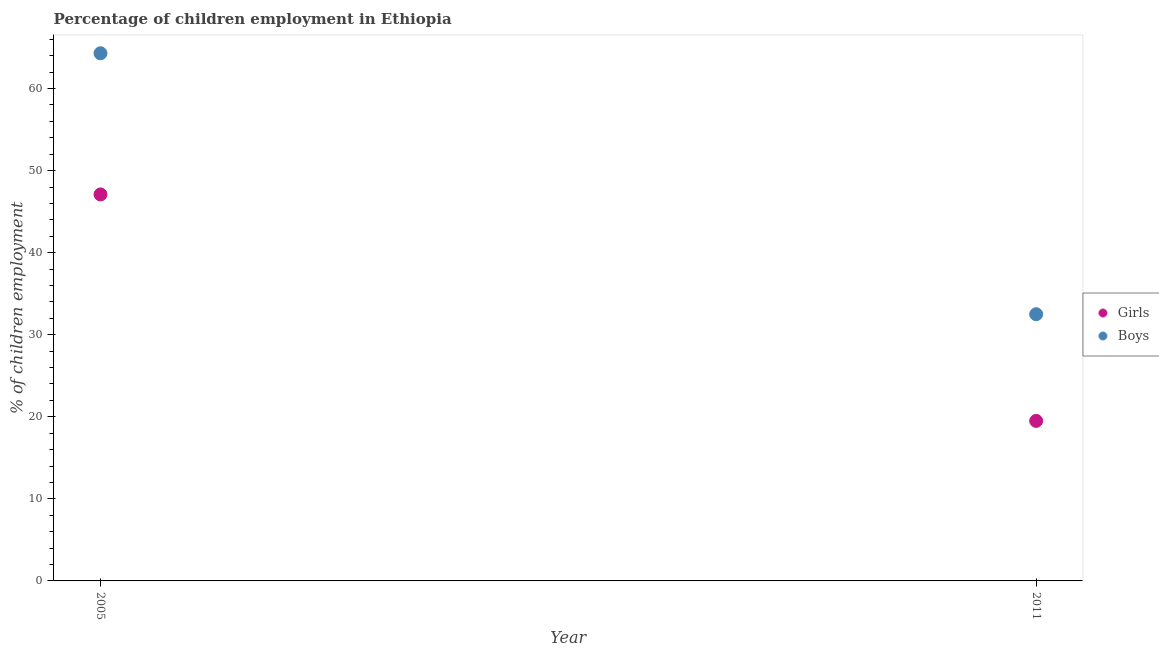Is the number of dotlines equal to the number of legend labels?
Offer a very short reply. Yes. What is the percentage of employed girls in 2011?
Your answer should be compact. 19.5. Across all years, what is the maximum percentage of employed boys?
Offer a very short reply. 64.3. Across all years, what is the minimum percentage of employed boys?
Your answer should be very brief. 32.5. In which year was the percentage of employed girls maximum?
Provide a succinct answer. 2005. What is the total percentage of employed boys in the graph?
Offer a terse response. 96.8. What is the difference between the percentage of employed boys in 2005 and that in 2011?
Provide a succinct answer. 31.8. What is the difference between the percentage of employed girls in 2011 and the percentage of employed boys in 2005?
Make the answer very short. -44.8. What is the average percentage of employed boys per year?
Offer a very short reply. 48.4. In how many years, is the percentage of employed boys greater than 50 %?
Keep it short and to the point. 1. What is the ratio of the percentage of employed girls in 2005 to that in 2011?
Offer a very short reply. 2.42. What is the difference between two consecutive major ticks on the Y-axis?
Offer a very short reply. 10. Does the graph contain any zero values?
Give a very brief answer. No. How many legend labels are there?
Your answer should be very brief. 2. How are the legend labels stacked?
Your response must be concise. Vertical. What is the title of the graph?
Provide a succinct answer. Percentage of children employment in Ethiopia. What is the label or title of the Y-axis?
Ensure brevity in your answer.  % of children employment. What is the % of children employment of Girls in 2005?
Offer a terse response. 47.1. What is the % of children employment in Boys in 2005?
Your answer should be compact. 64.3. What is the % of children employment in Boys in 2011?
Your response must be concise. 32.5. Across all years, what is the maximum % of children employment in Girls?
Give a very brief answer. 47.1. Across all years, what is the maximum % of children employment in Boys?
Provide a succinct answer. 64.3. Across all years, what is the minimum % of children employment of Boys?
Your response must be concise. 32.5. What is the total % of children employment of Girls in the graph?
Give a very brief answer. 66.6. What is the total % of children employment of Boys in the graph?
Make the answer very short. 96.8. What is the difference between the % of children employment in Girls in 2005 and that in 2011?
Offer a terse response. 27.6. What is the difference between the % of children employment of Boys in 2005 and that in 2011?
Provide a succinct answer. 31.8. What is the difference between the % of children employment in Girls in 2005 and the % of children employment in Boys in 2011?
Offer a very short reply. 14.6. What is the average % of children employment in Girls per year?
Ensure brevity in your answer.  33.3. What is the average % of children employment of Boys per year?
Ensure brevity in your answer.  48.4. In the year 2005, what is the difference between the % of children employment of Girls and % of children employment of Boys?
Make the answer very short. -17.2. In the year 2011, what is the difference between the % of children employment of Girls and % of children employment of Boys?
Ensure brevity in your answer.  -13. What is the ratio of the % of children employment of Girls in 2005 to that in 2011?
Provide a short and direct response. 2.42. What is the ratio of the % of children employment in Boys in 2005 to that in 2011?
Offer a very short reply. 1.98. What is the difference between the highest and the second highest % of children employment in Girls?
Keep it short and to the point. 27.6. What is the difference between the highest and the second highest % of children employment of Boys?
Offer a terse response. 31.8. What is the difference between the highest and the lowest % of children employment of Girls?
Give a very brief answer. 27.6. What is the difference between the highest and the lowest % of children employment in Boys?
Provide a short and direct response. 31.8. 